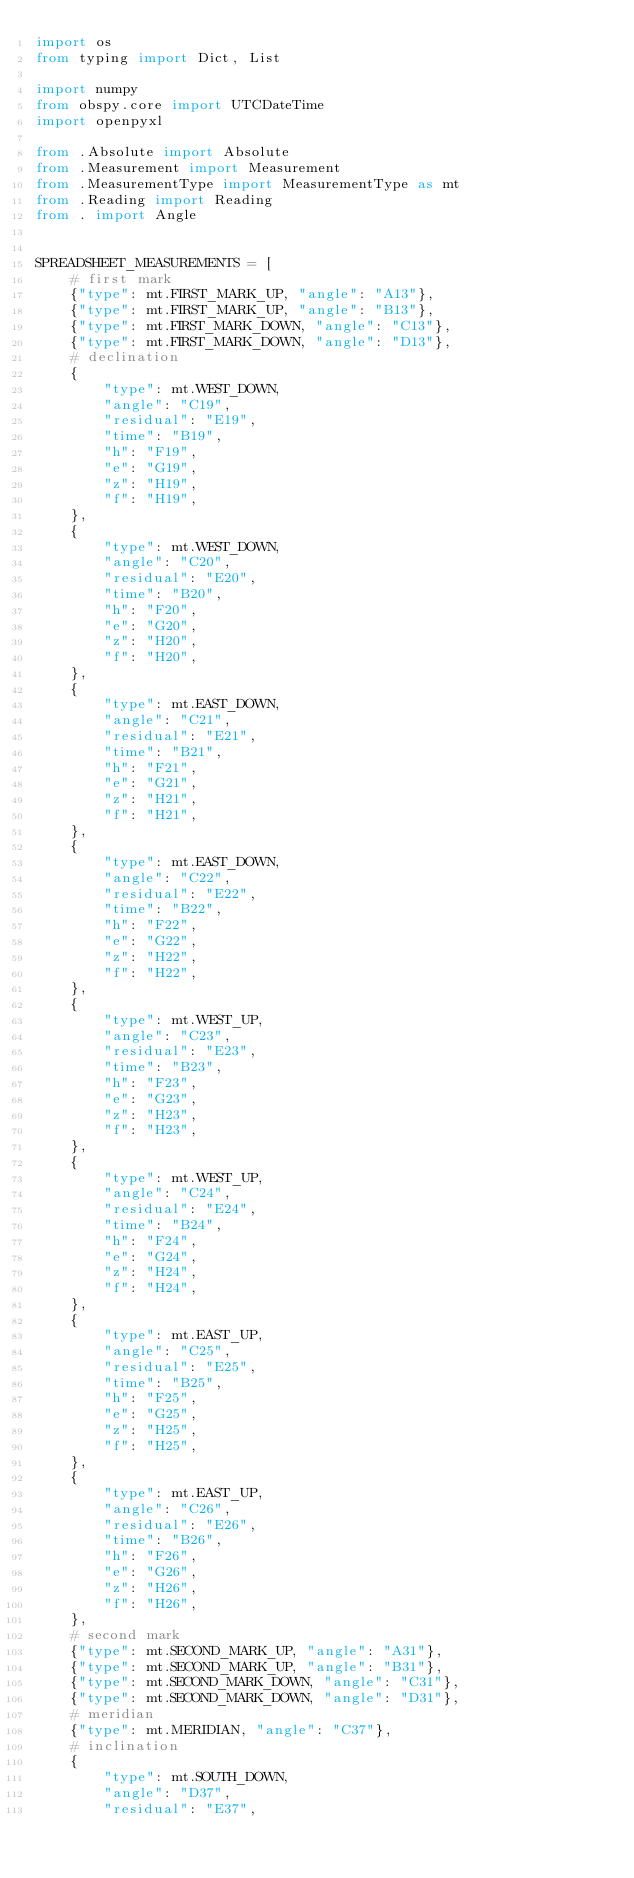<code> <loc_0><loc_0><loc_500><loc_500><_Python_>import os
from typing import Dict, List

import numpy
from obspy.core import UTCDateTime
import openpyxl

from .Absolute import Absolute
from .Measurement import Measurement
from .MeasurementType import MeasurementType as mt
from .Reading import Reading
from . import Angle


SPREADSHEET_MEASUREMENTS = [
    # first mark
    {"type": mt.FIRST_MARK_UP, "angle": "A13"},
    {"type": mt.FIRST_MARK_UP, "angle": "B13"},
    {"type": mt.FIRST_MARK_DOWN, "angle": "C13"},
    {"type": mt.FIRST_MARK_DOWN, "angle": "D13"},
    # declination
    {
        "type": mt.WEST_DOWN,
        "angle": "C19",
        "residual": "E19",
        "time": "B19",
        "h": "F19",
        "e": "G19",
        "z": "H19",
        "f": "H19",
    },
    {
        "type": mt.WEST_DOWN,
        "angle": "C20",
        "residual": "E20",
        "time": "B20",
        "h": "F20",
        "e": "G20",
        "z": "H20",
        "f": "H20",
    },
    {
        "type": mt.EAST_DOWN,
        "angle": "C21",
        "residual": "E21",
        "time": "B21",
        "h": "F21",
        "e": "G21",
        "z": "H21",
        "f": "H21",
    },
    {
        "type": mt.EAST_DOWN,
        "angle": "C22",
        "residual": "E22",
        "time": "B22",
        "h": "F22",
        "e": "G22",
        "z": "H22",
        "f": "H22",
    },
    {
        "type": mt.WEST_UP,
        "angle": "C23",
        "residual": "E23",
        "time": "B23",
        "h": "F23",
        "e": "G23",
        "z": "H23",
        "f": "H23",
    },
    {
        "type": mt.WEST_UP,
        "angle": "C24",
        "residual": "E24",
        "time": "B24",
        "h": "F24",
        "e": "G24",
        "z": "H24",
        "f": "H24",
    },
    {
        "type": mt.EAST_UP,
        "angle": "C25",
        "residual": "E25",
        "time": "B25",
        "h": "F25",
        "e": "G25",
        "z": "H25",
        "f": "H25",
    },
    {
        "type": mt.EAST_UP,
        "angle": "C26",
        "residual": "E26",
        "time": "B26",
        "h": "F26",
        "e": "G26",
        "z": "H26",
        "f": "H26",
    },
    # second mark
    {"type": mt.SECOND_MARK_UP, "angle": "A31"},
    {"type": mt.SECOND_MARK_UP, "angle": "B31"},
    {"type": mt.SECOND_MARK_DOWN, "angle": "C31"},
    {"type": mt.SECOND_MARK_DOWN, "angle": "D31"},
    # meridian
    {"type": mt.MERIDIAN, "angle": "C37"},
    # inclination
    {
        "type": mt.SOUTH_DOWN,
        "angle": "D37",
        "residual": "E37",</code> 